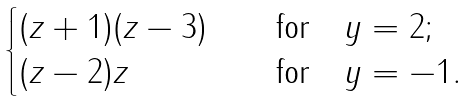<formula> <loc_0><loc_0><loc_500><loc_500>\begin{cases} ( z + 1 ) ( z - 3 ) \quad & \text {for} \quad y = 2 ; \\ ( z - 2 ) z \quad & \text {for} \quad y = - 1 . \\ \end{cases}</formula> 